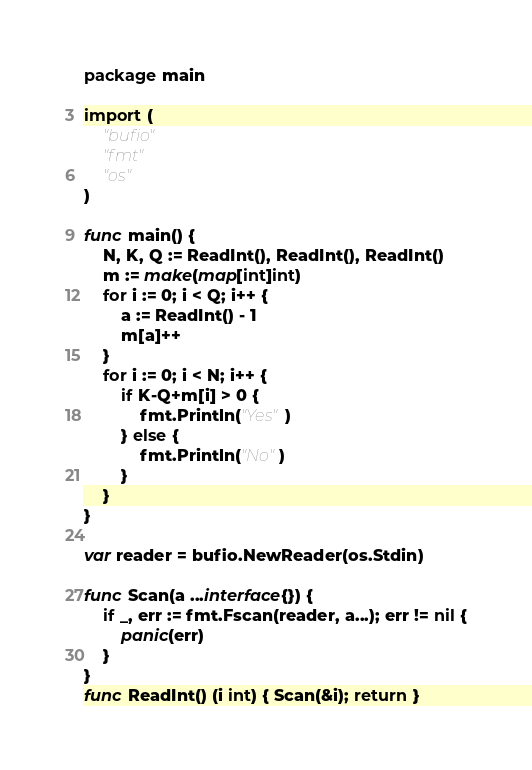Convert code to text. <code><loc_0><loc_0><loc_500><loc_500><_Go_>package main

import (
	"bufio"
	"fmt"
	"os"
)

func main() {
	N, K, Q := ReadInt(), ReadInt(), ReadInt()
	m := make(map[int]int)
	for i := 0; i < Q; i++ {
		a := ReadInt() - 1
		m[a]++
	}
	for i := 0; i < N; i++ {
		if K-Q+m[i] > 0 {
			fmt.Println("Yes")
		} else {
			fmt.Println("No")
		}
	}
}

var reader = bufio.NewReader(os.Stdin)

func Scan(a ...interface{}) {
	if _, err := fmt.Fscan(reader, a...); err != nil {
		panic(err)
	}
}
func ReadInt() (i int) { Scan(&i); return }
</code> 